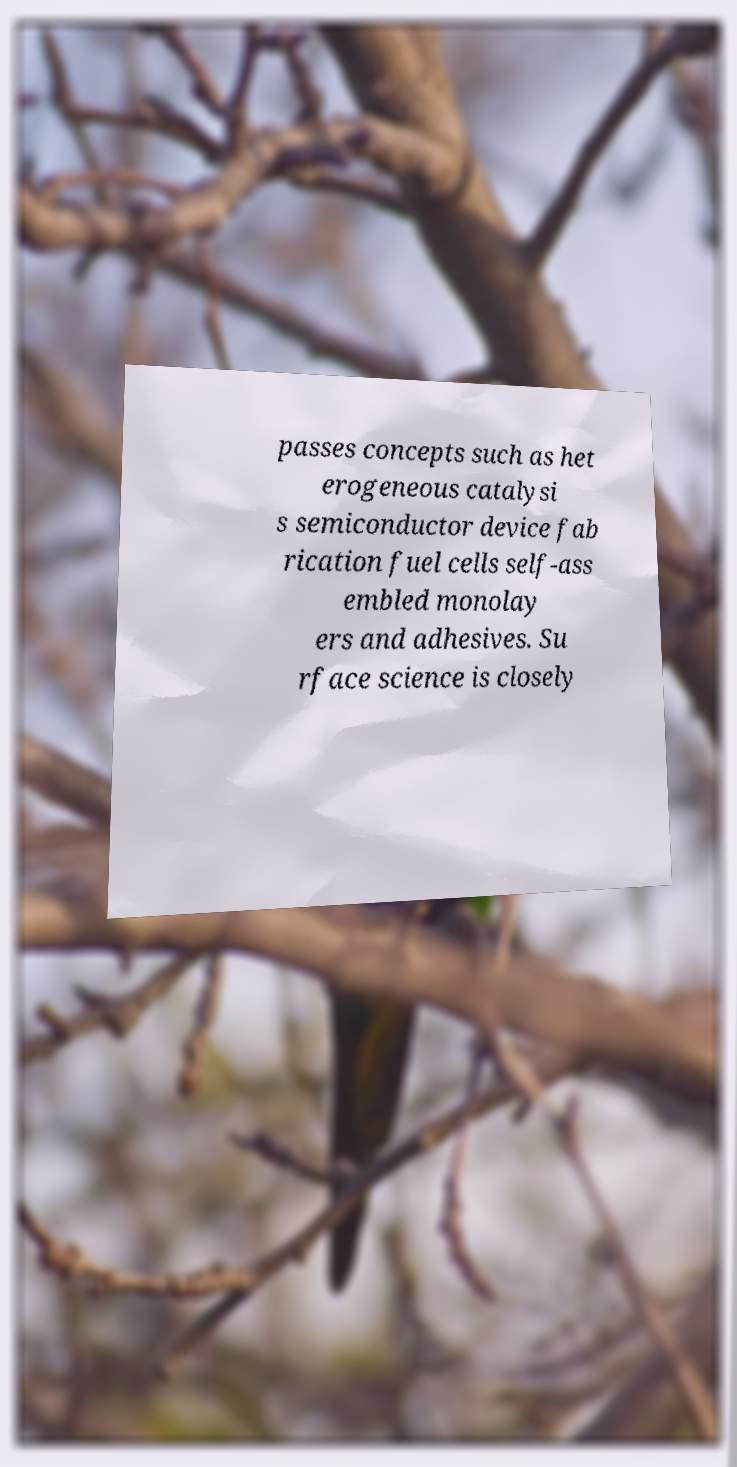Can you accurately transcribe the text from the provided image for me? passes concepts such as het erogeneous catalysi s semiconductor device fab rication fuel cells self-ass embled monolay ers and adhesives. Su rface science is closely 